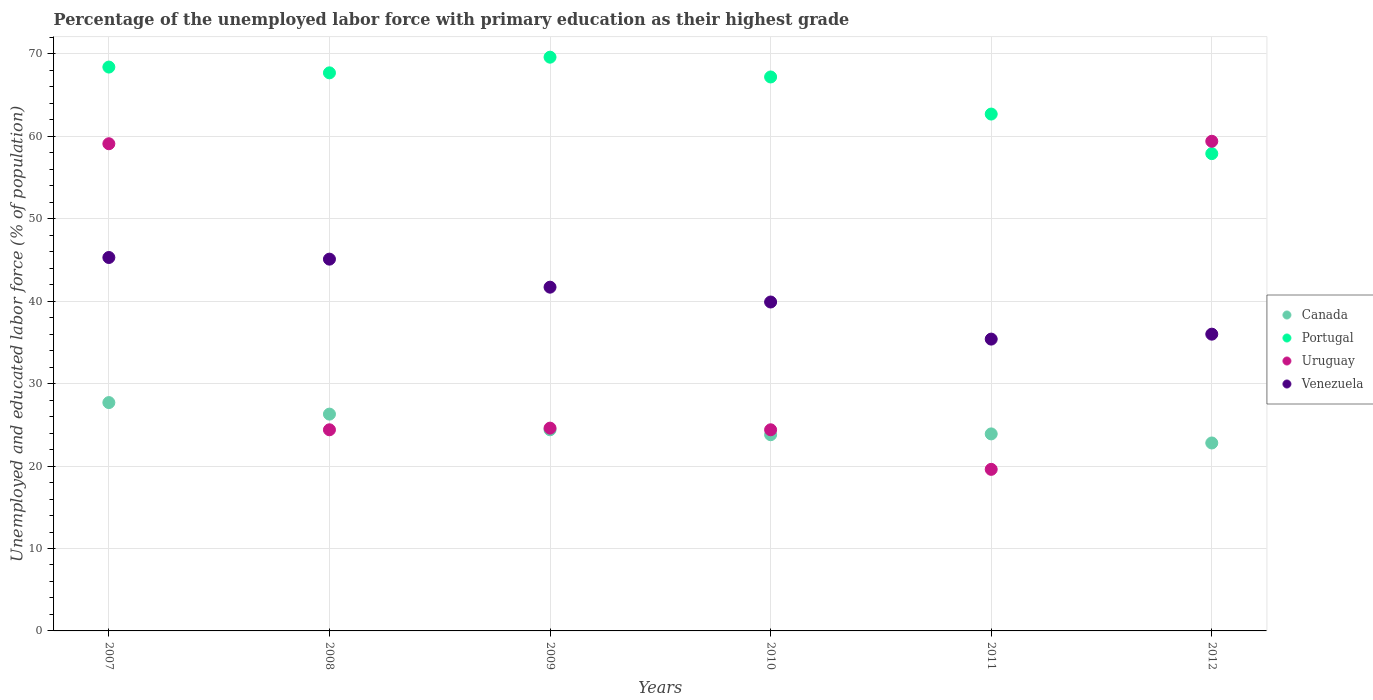How many different coloured dotlines are there?
Give a very brief answer. 4. What is the percentage of the unemployed labor force with primary education in Uruguay in 2008?
Give a very brief answer. 24.4. Across all years, what is the maximum percentage of the unemployed labor force with primary education in Portugal?
Give a very brief answer. 69.6. Across all years, what is the minimum percentage of the unemployed labor force with primary education in Canada?
Your response must be concise. 22.8. In which year was the percentage of the unemployed labor force with primary education in Canada maximum?
Offer a very short reply. 2007. What is the total percentage of the unemployed labor force with primary education in Uruguay in the graph?
Your answer should be very brief. 211.5. What is the difference between the percentage of the unemployed labor force with primary education in Uruguay in 2010 and that in 2011?
Offer a very short reply. 4.8. What is the difference between the percentage of the unemployed labor force with primary education in Uruguay in 2009 and the percentage of the unemployed labor force with primary education in Canada in 2007?
Give a very brief answer. -3.1. What is the average percentage of the unemployed labor force with primary education in Venezuela per year?
Give a very brief answer. 40.57. In the year 2011, what is the difference between the percentage of the unemployed labor force with primary education in Portugal and percentage of the unemployed labor force with primary education in Canada?
Offer a very short reply. 38.8. What is the ratio of the percentage of the unemployed labor force with primary education in Venezuela in 2007 to that in 2009?
Keep it short and to the point. 1.09. Is the percentage of the unemployed labor force with primary education in Portugal in 2009 less than that in 2012?
Offer a terse response. No. What is the difference between the highest and the second highest percentage of the unemployed labor force with primary education in Portugal?
Make the answer very short. 1.2. What is the difference between the highest and the lowest percentage of the unemployed labor force with primary education in Uruguay?
Your response must be concise. 39.8. In how many years, is the percentage of the unemployed labor force with primary education in Portugal greater than the average percentage of the unemployed labor force with primary education in Portugal taken over all years?
Offer a very short reply. 4. Is the sum of the percentage of the unemployed labor force with primary education in Canada in 2010 and 2012 greater than the maximum percentage of the unemployed labor force with primary education in Venezuela across all years?
Keep it short and to the point. Yes. Does the percentage of the unemployed labor force with primary education in Canada monotonically increase over the years?
Your answer should be compact. No. Is the percentage of the unemployed labor force with primary education in Uruguay strictly greater than the percentage of the unemployed labor force with primary education in Portugal over the years?
Keep it short and to the point. No. Is the percentage of the unemployed labor force with primary education in Canada strictly less than the percentage of the unemployed labor force with primary education in Portugal over the years?
Make the answer very short. Yes. How many dotlines are there?
Offer a terse response. 4. How many years are there in the graph?
Offer a terse response. 6. Does the graph contain grids?
Make the answer very short. Yes. Where does the legend appear in the graph?
Provide a succinct answer. Center right. How are the legend labels stacked?
Make the answer very short. Vertical. What is the title of the graph?
Provide a succinct answer. Percentage of the unemployed labor force with primary education as their highest grade. Does "Ukraine" appear as one of the legend labels in the graph?
Provide a short and direct response. No. What is the label or title of the Y-axis?
Offer a terse response. Unemployed and educated labor force (% of population). What is the Unemployed and educated labor force (% of population) of Canada in 2007?
Offer a terse response. 27.7. What is the Unemployed and educated labor force (% of population) of Portugal in 2007?
Give a very brief answer. 68.4. What is the Unemployed and educated labor force (% of population) of Uruguay in 2007?
Your response must be concise. 59.1. What is the Unemployed and educated labor force (% of population) of Venezuela in 2007?
Your response must be concise. 45.3. What is the Unemployed and educated labor force (% of population) in Canada in 2008?
Your answer should be compact. 26.3. What is the Unemployed and educated labor force (% of population) of Portugal in 2008?
Make the answer very short. 67.7. What is the Unemployed and educated labor force (% of population) in Uruguay in 2008?
Give a very brief answer. 24.4. What is the Unemployed and educated labor force (% of population) of Venezuela in 2008?
Provide a short and direct response. 45.1. What is the Unemployed and educated labor force (% of population) of Canada in 2009?
Your response must be concise. 24.4. What is the Unemployed and educated labor force (% of population) of Portugal in 2009?
Give a very brief answer. 69.6. What is the Unemployed and educated labor force (% of population) of Uruguay in 2009?
Ensure brevity in your answer.  24.6. What is the Unemployed and educated labor force (% of population) in Venezuela in 2009?
Your answer should be very brief. 41.7. What is the Unemployed and educated labor force (% of population) of Canada in 2010?
Your answer should be very brief. 23.8. What is the Unemployed and educated labor force (% of population) in Portugal in 2010?
Offer a terse response. 67.2. What is the Unemployed and educated labor force (% of population) of Uruguay in 2010?
Keep it short and to the point. 24.4. What is the Unemployed and educated labor force (% of population) of Venezuela in 2010?
Offer a terse response. 39.9. What is the Unemployed and educated labor force (% of population) in Canada in 2011?
Ensure brevity in your answer.  23.9. What is the Unemployed and educated labor force (% of population) of Portugal in 2011?
Give a very brief answer. 62.7. What is the Unemployed and educated labor force (% of population) of Uruguay in 2011?
Your response must be concise. 19.6. What is the Unemployed and educated labor force (% of population) in Venezuela in 2011?
Provide a succinct answer. 35.4. What is the Unemployed and educated labor force (% of population) in Canada in 2012?
Your response must be concise. 22.8. What is the Unemployed and educated labor force (% of population) of Portugal in 2012?
Your answer should be very brief. 57.9. What is the Unemployed and educated labor force (% of population) in Uruguay in 2012?
Offer a terse response. 59.4. Across all years, what is the maximum Unemployed and educated labor force (% of population) of Canada?
Make the answer very short. 27.7. Across all years, what is the maximum Unemployed and educated labor force (% of population) in Portugal?
Ensure brevity in your answer.  69.6. Across all years, what is the maximum Unemployed and educated labor force (% of population) of Uruguay?
Ensure brevity in your answer.  59.4. Across all years, what is the maximum Unemployed and educated labor force (% of population) of Venezuela?
Provide a short and direct response. 45.3. Across all years, what is the minimum Unemployed and educated labor force (% of population) of Canada?
Provide a short and direct response. 22.8. Across all years, what is the minimum Unemployed and educated labor force (% of population) of Portugal?
Keep it short and to the point. 57.9. Across all years, what is the minimum Unemployed and educated labor force (% of population) in Uruguay?
Offer a terse response. 19.6. Across all years, what is the minimum Unemployed and educated labor force (% of population) of Venezuela?
Offer a terse response. 35.4. What is the total Unemployed and educated labor force (% of population) of Canada in the graph?
Make the answer very short. 148.9. What is the total Unemployed and educated labor force (% of population) in Portugal in the graph?
Offer a very short reply. 393.5. What is the total Unemployed and educated labor force (% of population) in Uruguay in the graph?
Give a very brief answer. 211.5. What is the total Unemployed and educated labor force (% of population) in Venezuela in the graph?
Keep it short and to the point. 243.4. What is the difference between the Unemployed and educated labor force (% of population) in Uruguay in 2007 and that in 2008?
Keep it short and to the point. 34.7. What is the difference between the Unemployed and educated labor force (% of population) in Venezuela in 2007 and that in 2008?
Make the answer very short. 0.2. What is the difference between the Unemployed and educated labor force (% of population) in Canada in 2007 and that in 2009?
Offer a very short reply. 3.3. What is the difference between the Unemployed and educated labor force (% of population) of Uruguay in 2007 and that in 2009?
Your response must be concise. 34.5. What is the difference between the Unemployed and educated labor force (% of population) of Portugal in 2007 and that in 2010?
Keep it short and to the point. 1.2. What is the difference between the Unemployed and educated labor force (% of population) of Uruguay in 2007 and that in 2010?
Your answer should be compact. 34.7. What is the difference between the Unemployed and educated labor force (% of population) in Venezuela in 2007 and that in 2010?
Give a very brief answer. 5.4. What is the difference between the Unemployed and educated labor force (% of population) in Uruguay in 2007 and that in 2011?
Your answer should be very brief. 39.5. What is the difference between the Unemployed and educated labor force (% of population) of Portugal in 2007 and that in 2012?
Make the answer very short. 10.5. What is the difference between the Unemployed and educated labor force (% of population) of Uruguay in 2007 and that in 2012?
Your answer should be compact. -0.3. What is the difference between the Unemployed and educated labor force (% of population) in Portugal in 2008 and that in 2009?
Provide a short and direct response. -1.9. What is the difference between the Unemployed and educated labor force (% of population) of Uruguay in 2008 and that in 2009?
Your response must be concise. -0.2. What is the difference between the Unemployed and educated labor force (% of population) of Venezuela in 2008 and that in 2009?
Your response must be concise. 3.4. What is the difference between the Unemployed and educated labor force (% of population) in Canada in 2008 and that in 2010?
Your answer should be very brief. 2.5. What is the difference between the Unemployed and educated labor force (% of population) of Canada in 2008 and that in 2011?
Offer a terse response. 2.4. What is the difference between the Unemployed and educated labor force (% of population) in Portugal in 2008 and that in 2011?
Offer a very short reply. 5. What is the difference between the Unemployed and educated labor force (% of population) in Venezuela in 2008 and that in 2011?
Make the answer very short. 9.7. What is the difference between the Unemployed and educated labor force (% of population) in Canada in 2008 and that in 2012?
Offer a terse response. 3.5. What is the difference between the Unemployed and educated labor force (% of population) in Portugal in 2008 and that in 2012?
Ensure brevity in your answer.  9.8. What is the difference between the Unemployed and educated labor force (% of population) of Uruguay in 2008 and that in 2012?
Your answer should be compact. -35. What is the difference between the Unemployed and educated labor force (% of population) in Venezuela in 2008 and that in 2012?
Keep it short and to the point. 9.1. What is the difference between the Unemployed and educated labor force (% of population) in Canada in 2009 and that in 2010?
Your answer should be very brief. 0.6. What is the difference between the Unemployed and educated labor force (% of population) in Portugal in 2009 and that in 2010?
Offer a terse response. 2.4. What is the difference between the Unemployed and educated labor force (% of population) in Venezuela in 2009 and that in 2010?
Ensure brevity in your answer.  1.8. What is the difference between the Unemployed and educated labor force (% of population) in Canada in 2009 and that in 2011?
Keep it short and to the point. 0.5. What is the difference between the Unemployed and educated labor force (% of population) of Uruguay in 2009 and that in 2011?
Ensure brevity in your answer.  5. What is the difference between the Unemployed and educated labor force (% of population) of Uruguay in 2009 and that in 2012?
Provide a short and direct response. -34.8. What is the difference between the Unemployed and educated labor force (% of population) of Venezuela in 2009 and that in 2012?
Offer a very short reply. 5.7. What is the difference between the Unemployed and educated labor force (% of population) of Portugal in 2010 and that in 2012?
Ensure brevity in your answer.  9.3. What is the difference between the Unemployed and educated labor force (% of population) of Uruguay in 2010 and that in 2012?
Ensure brevity in your answer.  -35. What is the difference between the Unemployed and educated labor force (% of population) of Venezuela in 2010 and that in 2012?
Offer a terse response. 3.9. What is the difference between the Unemployed and educated labor force (% of population) in Uruguay in 2011 and that in 2012?
Provide a succinct answer. -39.8. What is the difference between the Unemployed and educated labor force (% of population) in Canada in 2007 and the Unemployed and educated labor force (% of population) in Portugal in 2008?
Offer a very short reply. -40. What is the difference between the Unemployed and educated labor force (% of population) of Canada in 2007 and the Unemployed and educated labor force (% of population) of Venezuela in 2008?
Provide a succinct answer. -17.4. What is the difference between the Unemployed and educated labor force (% of population) of Portugal in 2007 and the Unemployed and educated labor force (% of population) of Venezuela in 2008?
Your answer should be very brief. 23.3. What is the difference between the Unemployed and educated labor force (% of population) in Canada in 2007 and the Unemployed and educated labor force (% of population) in Portugal in 2009?
Offer a very short reply. -41.9. What is the difference between the Unemployed and educated labor force (% of population) of Canada in 2007 and the Unemployed and educated labor force (% of population) of Venezuela in 2009?
Your answer should be compact. -14. What is the difference between the Unemployed and educated labor force (% of population) in Portugal in 2007 and the Unemployed and educated labor force (% of population) in Uruguay in 2009?
Give a very brief answer. 43.8. What is the difference between the Unemployed and educated labor force (% of population) of Portugal in 2007 and the Unemployed and educated labor force (% of population) of Venezuela in 2009?
Provide a short and direct response. 26.7. What is the difference between the Unemployed and educated labor force (% of population) in Uruguay in 2007 and the Unemployed and educated labor force (% of population) in Venezuela in 2009?
Ensure brevity in your answer.  17.4. What is the difference between the Unemployed and educated labor force (% of population) of Canada in 2007 and the Unemployed and educated labor force (% of population) of Portugal in 2010?
Give a very brief answer. -39.5. What is the difference between the Unemployed and educated labor force (% of population) in Canada in 2007 and the Unemployed and educated labor force (% of population) in Venezuela in 2010?
Make the answer very short. -12.2. What is the difference between the Unemployed and educated labor force (% of population) in Uruguay in 2007 and the Unemployed and educated labor force (% of population) in Venezuela in 2010?
Ensure brevity in your answer.  19.2. What is the difference between the Unemployed and educated labor force (% of population) of Canada in 2007 and the Unemployed and educated labor force (% of population) of Portugal in 2011?
Offer a terse response. -35. What is the difference between the Unemployed and educated labor force (% of population) in Canada in 2007 and the Unemployed and educated labor force (% of population) in Uruguay in 2011?
Your answer should be compact. 8.1. What is the difference between the Unemployed and educated labor force (% of population) in Canada in 2007 and the Unemployed and educated labor force (% of population) in Venezuela in 2011?
Give a very brief answer. -7.7. What is the difference between the Unemployed and educated labor force (% of population) of Portugal in 2007 and the Unemployed and educated labor force (% of population) of Uruguay in 2011?
Offer a very short reply. 48.8. What is the difference between the Unemployed and educated labor force (% of population) of Portugal in 2007 and the Unemployed and educated labor force (% of population) of Venezuela in 2011?
Ensure brevity in your answer.  33. What is the difference between the Unemployed and educated labor force (% of population) of Uruguay in 2007 and the Unemployed and educated labor force (% of population) of Venezuela in 2011?
Give a very brief answer. 23.7. What is the difference between the Unemployed and educated labor force (% of population) in Canada in 2007 and the Unemployed and educated labor force (% of population) in Portugal in 2012?
Make the answer very short. -30.2. What is the difference between the Unemployed and educated labor force (% of population) of Canada in 2007 and the Unemployed and educated labor force (% of population) of Uruguay in 2012?
Keep it short and to the point. -31.7. What is the difference between the Unemployed and educated labor force (% of population) of Portugal in 2007 and the Unemployed and educated labor force (% of population) of Uruguay in 2012?
Provide a short and direct response. 9. What is the difference between the Unemployed and educated labor force (% of population) of Portugal in 2007 and the Unemployed and educated labor force (% of population) of Venezuela in 2012?
Offer a terse response. 32.4. What is the difference between the Unemployed and educated labor force (% of population) of Uruguay in 2007 and the Unemployed and educated labor force (% of population) of Venezuela in 2012?
Provide a short and direct response. 23.1. What is the difference between the Unemployed and educated labor force (% of population) in Canada in 2008 and the Unemployed and educated labor force (% of population) in Portugal in 2009?
Offer a very short reply. -43.3. What is the difference between the Unemployed and educated labor force (% of population) in Canada in 2008 and the Unemployed and educated labor force (% of population) in Uruguay in 2009?
Provide a succinct answer. 1.7. What is the difference between the Unemployed and educated labor force (% of population) of Canada in 2008 and the Unemployed and educated labor force (% of population) of Venezuela in 2009?
Make the answer very short. -15.4. What is the difference between the Unemployed and educated labor force (% of population) in Portugal in 2008 and the Unemployed and educated labor force (% of population) in Uruguay in 2009?
Your response must be concise. 43.1. What is the difference between the Unemployed and educated labor force (% of population) of Portugal in 2008 and the Unemployed and educated labor force (% of population) of Venezuela in 2009?
Your answer should be compact. 26. What is the difference between the Unemployed and educated labor force (% of population) in Uruguay in 2008 and the Unemployed and educated labor force (% of population) in Venezuela in 2009?
Offer a very short reply. -17.3. What is the difference between the Unemployed and educated labor force (% of population) of Canada in 2008 and the Unemployed and educated labor force (% of population) of Portugal in 2010?
Make the answer very short. -40.9. What is the difference between the Unemployed and educated labor force (% of population) in Canada in 2008 and the Unemployed and educated labor force (% of population) in Uruguay in 2010?
Keep it short and to the point. 1.9. What is the difference between the Unemployed and educated labor force (% of population) in Portugal in 2008 and the Unemployed and educated labor force (% of population) in Uruguay in 2010?
Provide a short and direct response. 43.3. What is the difference between the Unemployed and educated labor force (% of population) in Portugal in 2008 and the Unemployed and educated labor force (% of population) in Venezuela in 2010?
Make the answer very short. 27.8. What is the difference between the Unemployed and educated labor force (% of population) of Uruguay in 2008 and the Unemployed and educated labor force (% of population) of Venezuela in 2010?
Your response must be concise. -15.5. What is the difference between the Unemployed and educated labor force (% of population) in Canada in 2008 and the Unemployed and educated labor force (% of population) in Portugal in 2011?
Provide a succinct answer. -36.4. What is the difference between the Unemployed and educated labor force (% of population) in Portugal in 2008 and the Unemployed and educated labor force (% of population) in Uruguay in 2011?
Provide a succinct answer. 48.1. What is the difference between the Unemployed and educated labor force (% of population) of Portugal in 2008 and the Unemployed and educated labor force (% of population) of Venezuela in 2011?
Provide a succinct answer. 32.3. What is the difference between the Unemployed and educated labor force (% of population) of Uruguay in 2008 and the Unemployed and educated labor force (% of population) of Venezuela in 2011?
Keep it short and to the point. -11. What is the difference between the Unemployed and educated labor force (% of population) in Canada in 2008 and the Unemployed and educated labor force (% of population) in Portugal in 2012?
Provide a short and direct response. -31.6. What is the difference between the Unemployed and educated labor force (% of population) of Canada in 2008 and the Unemployed and educated labor force (% of population) of Uruguay in 2012?
Your answer should be very brief. -33.1. What is the difference between the Unemployed and educated labor force (% of population) in Portugal in 2008 and the Unemployed and educated labor force (% of population) in Uruguay in 2012?
Provide a short and direct response. 8.3. What is the difference between the Unemployed and educated labor force (% of population) in Portugal in 2008 and the Unemployed and educated labor force (% of population) in Venezuela in 2012?
Your response must be concise. 31.7. What is the difference between the Unemployed and educated labor force (% of population) in Uruguay in 2008 and the Unemployed and educated labor force (% of population) in Venezuela in 2012?
Your answer should be compact. -11.6. What is the difference between the Unemployed and educated labor force (% of population) of Canada in 2009 and the Unemployed and educated labor force (% of population) of Portugal in 2010?
Ensure brevity in your answer.  -42.8. What is the difference between the Unemployed and educated labor force (% of population) in Canada in 2009 and the Unemployed and educated labor force (% of population) in Uruguay in 2010?
Ensure brevity in your answer.  0. What is the difference between the Unemployed and educated labor force (% of population) of Canada in 2009 and the Unemployed and educated labor force (% of population) of Venezuela in 2010?
Offer a terse response. -15.5. What is the difference between the Unemployed and educated labor force (% of population) in Portugal in 2009 and the Unemployed and educated labor force (% of population) in Uruguay in 2010?
Make the answer very short. 45.2. What is the difference between the Unemployed and educated labor force (% of population) in Portugal in 2009 and the Unemployed and educated labor force (% of population) in Venezuela in 2010?
Ensure brevity in your answer.  29.7. What is the difference between the Unemployed and educated labor force (% of population) of Uruguay in 2009 and the Unemployed and educated labor force (% of population) of Venezuela in 2010?
Provide a short and direct response. -15.3. What is the difference between the Unemployed and educated labor force (% of population) of Canada in 2009 and the Unemployed and educated labor force (% of population) of Portugal in 2011?
Offer a terse response. -38.3. What is the difference between the Unemployed and educated labor force (% of population) of Portugal in 2009 and the Unemployed and educated labor force (% of population) of Venezuela in 2011?
Your response must be concise. 34.2. What is the difference between the Unemployed and educated labor force (% of population) of Uruguay in 2009 and the Unemployed and educated labor force (% of population) of Venezuela in 2011?
Provide a short and direct response. -10.8. What is the difference between the Unemployed and educated labor force (% of population) in Canada in 2009 and the Unemployed and educated labor force (% of population) in Portugal in 2012?
Give a very brief answer. -33.5. What is the difference between the Unemployed and educated labor force (% of population) of Canada in 2009 and the Unemployed and educated labor force (% of population) of Uruguay in 2012?
Give a very brief answer. -35. What is the difference between the Unemployed and educated labor force (% of population) of Portugal in 2009 and the Unemployed and educated labor force (% of population) of Uruguay in 2012?
Your response must be concise. 10.2. What is the difference between the Unemployed and educated labor force (% of population) in Portugal in 2009 and the Unemployed and educated labor force (% of population) in Venezuela in 2012?
Provide a succinct answer. 33.6. What is the difference between the Unemployed and educated labor force (% of population) in Uruguay in 2009 and the Unemployed and educated labor force (% of population) in Venezuela in 2012?
Offer a terse response. -11.4. What is the difference between the Unemployed and educated labor force (% of population) in Canada in 2010 and the Unemployed and educated labor force (% of population) in Portugal in 2011?
Ensure brevity in your answer.  -38.9. What is the difference between the Unemployed and educated labor force (% of population) in Canada in 2010 and the Unemployed and educated labor force (% of population) in Uruguay in 2011?
Offer a terse response. 4.2. What is the difference between the Unemployed and educated labor force (% of population) in Portugal in 2010 and the Unemployed and educated labor force (% of population) in Uruguay in 2011?
Make the answer very short. 47.6. What is the difference between the Unemployed and educated labor force (% of population) of Portugal in 2010 and the Unemployed and educated labor force (% of population) of Venezuela in 2011?
Provide a succinct answer. 31.8. What is the difference between the Unemployed and educated labor force (% of population) in Uruguay in 2010 and the Unemployed and educated labor force (% of population) in Venezuela in 2011?
Provide a short and direct response. -11. What is the difference between the Unemployed and educated labor force (% of population) of Canada in 2010 and the Unemployed and educated labor force (% of population) of Portugal in 2012?
Your response must be concise. -34.1. What is the difference between the Unemployed and educated labor force (% of population) in Canada in 2010 and the Unemployed and educated labor force (% of population) in Uruguay in 2012?
Provide a short and direct response. -35.6. What is the difference between the Unemployed and educated labor force (% of population) in Canada in 2010 and the Unemployed and educated labor force (% of population) in Venezuela in 2012?
Your answer should be very brief. -12.2. What is the difference between the Unemployed and educated labor force (% of population) in Portugal in 2010 and the Unemployed and educated labor force (% of population) in Uruguay in 2012?
Give a very brief answer. 7.8. What is the difference between the Unemployed and educated labor force (% of population) in Portugal in 2010 and the Unemployed and educated labor force (% of population) in Venezuela in 2012?
Make the answer very short. 31.2. What is the difference between the Unemployed and educated labor force (% of population) of Uruguay in 2010 and the Unemployed and educated labor force (% of population) of Venezuela in 2012?
Your response must be concise. -11.6. What is the difference between the Unemployed and educated labor force (% of population) in Canada in 2011 and the Unemployed and educated labor force (% of population) in Portugal in 2012?
Your answer should be compact. -34. What is the difference between the Unemployed and educated labor force (% of population) of Canada in 2011 and the Unemployed and educated labor force (% of population) of Uruguay in 2012?
Make the answer very short. -35.5. What is the difference between the Unemployed and educated labor force (% of population) in Canada in 2011 and the Unemployed and educated labor force (% of population) in Venezuela in 2012?
Offer a terse response. -12.1. What is the difference between the Unemployed and educated labor force (% of population) of Portugal in 2011 and the Unemployed and educated labor force (% of population) of Venezuela in 2012?
Offer a terse response. 26.7. What is the difference between the Unemployed and educated labor force (% of population) in Uruguay in 2011 and the Unemployed and educated labor force (% of population) in Venezuela in 2012?
Your response must be concise. -16.4. What is the average Unemployed and educated labor force (% of population) of Canada per year?
Offer a terse response. 24.82. What is the average Unemployed and educated labor force (% of population) in Portugal per year?
Give a very brief answer. 65.58. What is the average Unemployed and educated labor force (% of population) of Uruguay per year?
Offer a terse response. 35.25. What is the average Unemployed and educated labor force (% of population) of Venezuela per year?
Make the answer very short. 40.57. In the year 2007, what is the difference between the Unemployed and educated labor force (% of population) in Canada and Unemployed and educated labor force (% of population) in Portugal?
Keep it short and to the point. -40.7. In the year 2007, what is the difference between the Unemployed and educated labor force (% of population) in Canada and Unemployed and educated labor force (% of population) in Uruguay?
Make the answer very short. -31.4. In the year 2007, what is the difference between the Unemployed and educated labor force (% of population) of Canada and Unemployed and educated labor force (% of population) of Venezuela?
Your answer should be very brief. -17.6. In the year 2007, what is the difference between the Unemployed and educated labor force (% of population) of Portugal and Unemployed and educated labor force (% of population) of Uruguay?
Make the answer very short. 9.3. In the year 2007, what is the difference between the Unemployed and educated labor force (% of population) in Portugal and Unemployed and educated labor force (% of population) in Venezuela?
Your answer should be compact. 23.1. In the year 2008, what is the difference between the Unemployed and educated labor force (% of population) in Canada and Unemployed and educated labor force (% of population) in Portugal?
Ensure brevity in your answer.  -41.4. In the year 2008, what is the difference between the Unemployed and educated labor force (% of population) in Canada and Unemployed and educated labor force (% of population) in Uruguay?
Give a very brief answer. 1.9. In the year 2008, what is the difference between the Unemployed and educated labor force (% of population) of Canada and Unemployed and educated labor force (% of population) of Venezuela?
Provide a succinct answer. -18.8. In the year 2008, what is the difference between the Unemployed and educated labor force (% of population) in Portugal and Unemployed and educated labor force (% of population) in Uruguay?
Offer a very short reply. 43.3. In the year 2008, what is the difference between the Unemployed and educated labor force (% of population) in Portugal and Unemployed and educated labor force (% of population) in Venezuela?
Your answer should be very brief. 22.6. In the year 2008, what is the difference between the Unemployed and educated labor force (% of population) in Uruguay and Unemployed and educated labor force (% of population) in Venezuela?
Offer a very short reply. -20.7. In the year 2009, what is the difference between the Unemployed and educated labor force (% of population) in Canada and Unemployed and educated labor force (% of population) in Portugal?
Your answer should be very brief. -45.2. In the year 2009, what is the difference between the Unemployed and educated labor force (% of population) of Canada and Unemployed and educated labor force (% of population) of Venezuela?
Provide a succinct answer. -17.3. In the year 2009, what is the difference between the Unemployed and educated labor force (% of population) in Portugal and Unemployed and educated labor force (% of population) in Venezuela?
Your answer should be compact. 27.9. In the year 2009, what is the difference between the Unemployed and educated labor force (% of population) of Uruguay and Unemployed and educated labor force (% of population) of Venezuela?
Your answer should be compact. -17.1. In the year 2010, what is the difference between the Unemployed and educated labor force (% of population) of Canada and Unemployed and educated labor force (% of population) of Portugal?
Make the answer very short. -43.4. In the year 2010, what is the difference between the Unemployed and educated labor force (% of population) in Canada and Unemployed and educated labor force (% of population) in Uruguay?
Your answer should be compact. -0.6. In the year 2010, what is the difference between the Unemployed and educated labor force (% of population) of Canada and Unemployed and educated labor force (% of population) of Venezuela?
Give a very brief answer. -16.1. In the year 2010, what is the difference between the Unemployed and educated labor force (% of population) in Portugal and Unemployed and educated labor force (% of population) in Uruguay?
Offer a terse response. 42.8. In the year 2010, what is the difference between the Unemployed and educated labor force (% of population) in Portugal and Unemployed and educated labor force (% of population) in Venezuela?
Make the answer very short. 27.3. In the year 2010, what is the difference between the Unemployed and educated labor force (% of population) of Uruguay and Unemployed and educated labor force (% of population) of Venezuela?
Provide a succinct answer. -15.5. In the year 2011, what is the difference between the Unemployed and educated labor force (% of population) of Canada and Unemployed and educated labor force (% of population) of Portugal?
Your response must be concise. -38.8. In the year 2011, what is the difference between the Unemployed and educated labor force (% of population) in Canada and Unemployed and educated labor force (% of population) in Uruguay?
Ensure brevity in your answer.  4.3. In the year 2011, what is the difference between the Unemployed and educated labor force (% of population) in Portugal and Unemployed and educated labor force (% of population) in Uruguay?
Make the answer very short. 43.1. In the year 2011, what is the difference between the Unemployed and educated labor force (% of population) in Portugal and Unemployed and educated labor force (% of population) in Venezuela?
Give a very brief answer. 27.3. In the year 2011, what is the difference between the Unemployed and educated labor force (% of population) of Uruguay and Unemployed and educated labor force (% of population) of Venezuela?
Keep it short and to the point. -15.8. In the year 2012, what is the difference between the Unemployed and educated labor force (% of population) in Canada and Unemployed and educated labor force (% of population) in Portugal?
Make the answer very short. -35.1. In the year 2012, what is the difference between the Unemployed and educated labor force (% of population) of Canada and Unemployed and educated labor force (% of population) of Uruguay?
Ensure brevity in your answer.  -36.6. In the year 2012, what is the difference between the Unemployed and educated labor force (% of population) in Canada and Unemployed and educated labor force (% of population) in Venezuela?
Keep it short and to the point. -13.2. In the year 2012, what is the difference between the Unemployed and educated labor force (% of population) in Portugal and Unemployed and educated labor force (% of population) in Venezuela?
Offer a very short reply. 21.9. In the year 2012, what is the difference between the Unemployed and educated labor force (% of population) of Uruguay and Unemployed and educated labor force (% of population) of Venezuela?
Provide a succinct answer. 23.4. What is the ratio of the Unemployed and educated labor force (% of population) in Canada in 2007 to that in 2008?
Offer a very short reply. 1.05. What is the ratio of the Unemployed and educated labor force (% of population) of Portugal in 2007 to that in 2008?
Your answer should be compact. 1.01. What is the ratio of the Unemployed and educated labor force (% of population) in Uruguay in 2007 to that in 2008?
Make the answer very short. 2.42. What is the ratio of the Unemployed and educated labor force (% of population) in Canada in 2007 to that in 2009?
Give a very brief answer. 1.14. What is the ratio of the Unemployed and educated labor force (% of population) of Portugal in 2007 to that in 2009?
Provide a succinct answer. 0.98. What is the ratio of the Unemployed and educated labor force (% of population) of Uruguay in 2007 to that in 2009?
Offer a very short reply. 2.4. What is the ratio of the Unemployed and educated labor force (% of population) in Venezuela in 2007 to that in 2009?
Your answer should be very brief. 1.09. What is the ratio of the Unemployed and educated labor force (% of population) of Canada in 2007 to that in 2010?
Your answer should be very brief. 1.16. What is the ratio of the Unemployed and educated labor force (% of population) of Portugal in 2007 to that in 2010?
Offer a very short reply. 1.02. What is the ratio of the Unemployed and educated labor force (% of population) in Uruguay in 2007 to that in 2010?
Your answer should be compact. 2.42. What is the ratio of the Unemployed and educated labor force (% of population) in Venezuela in 2007 to that in 2010?
Your answer should be compact. 1.14. What is the ratio of the Unemployed and educated labor force (% of population) in Canada in 2007 to that in 2011?
Give a very brief answer. 1.16. What is the ratio of the Unemployed and educated labor force (% of population) in Portugal in 2007 to that in 2011?
Your response must be concise. 1.09. What is the ratio of the Unemployed and educated labor force (% of population) of Uruguay in 2007 to that in 2011?
Keep it short and to the point. 3.02. What is the ratio of the Unemployed and educated labor force (% of population) in Venezuela in 2007 to that in 2011?
Give a very brief answer. 1.28. What is the ratio of the Unemployed and educated labor force (% of population) of Canada in 2007 to that in 2012?
Provide a short and direct response. 1.21. What is the ratio of the Unemployed and educated labor force (% of population) in Portugal in 2007 to that in 2012?
Provide a succinct answer. 1.18. What is the ratio of the Unemployed and educated labor force (% of population) of Venezuela in 2007 to that in 2012?
Offer a terse response. 1.26. What is the ratio of the Unemployed and educated labor force (% of population) in Canada in 2008 to that in 2009?
Make the answer very short. 1.08. What is the ratio of the Unemployed and educated labor force (% of population) of Portugal in 2008 to that in 2009?
Your answer should be compact. 0.97. What is the ratio of the Unemployed and educated labor force (% of population) in Venezuela in 2008 to that in 2009?
Offer a terse response. 1.08. What is the ratio of the Unemployed and educated labor force (% of population) in Canada in 2008 to that in 2010?
Offer a very short reply. 1.1. What is the ratio of the Unemployed and educated labor force (% of population) of Portugal in 2008 to that in 2010?
Keep it short and to the point. 1.01. What is the ratio of the Unemployed and educated labor force (% of population) in Venezuela in 2008 to that in 2010?
Your answer should be very brief. 1.13. What is the ratio of the Unemployed and educated labor force (% of population) in Canada in 2008 to that in 2011?
Provide a succinct answer. 1.1. What is the ratio of the Unemployed and educated labor force (% of population) of Portugal in 2008 to that in 2011?
Keep it short and to the point. 1.08. What is the ratio of the Unemployed and educated labor force (% of population) of Uruguay in 2008 to that in 2011?
Provide a succinct answer. 1.24. What is the ratio of the Unemployed and educated labor force (% of population) of Venezuela in 2008 to that in 2011?
Offer a very short reply. 1.27. What is the ratio of the Unemployed and educated labor force (% of population) in Canada in 2008 to that in 2012?
Keep it short and to the point. 1.15. What is the ratio of the Unemployed and educated labor force (% of population) of Portugal in 2008 to that in 2012?
Make the answer very short. 1.17. What is the ratio of the Unemployed and educated labor force (% of population) in Uruguay in 2008 to that in 2012?
Offer a very short reply. 0.41. What is the ratio of the Unemployed and educated labor force (% of population) in Venezuela in 2008 to that in 2012?
Your response must be concise. 1.25. What is the ratio of the Unemployed and educated labor force (% of population) of Canada in 2009 to that in 2010?
Ensure brevity in your answer.  1.03. What is the ratio of the Unemployed and educated labor force (% of population) of Portugal in 2009 to that in 2010?
Give a very brief answer. 1.04. What is the ratio of the Unemployed and educated labor force (% of population) of Uruguay in 2009 to that in 2010?
Make the answer very short. 1.01. What is the ratio of the Unemployed and educated labor force (% of population) in Venezuela in 2009 to that in 2010?
Keep it short and to the point. 1.05. What is the ratio of the Unemployed and educated labor force (% of population) in Canada in 2009 to that in 2011?
Your response must be concise. 1.02. What is the ratio of the Unemployed and educated labor force (% of population) in Portugal in 2009 to that in 2011?
Provide a short and direct response. 1.11. What is the ratio of the Unemployed and educated labor force (% of population) in Uruguay in 2009 to that in 2011?
Keep it short and to the point. 1.26. What is the ratio of the Unemployed and educated labor force (% of population) of Venezuela in 2009 to that in 2011?
Give a very brief answer. 1.18. What is the ratio of the Unemployed and educated labor force (% of population) in Canada in 2009 to that in 2012?
Offer a terse response. 1.07. What is the ratio of the Unemployed and educated labor force (% of population) of Portugal in 2009 to that in 2012?
Provide a short and direct response. 1.2. What is the ratio of the Unemployed and educated labor force (% of population) of Uruguay in 2009 to that in 2012?
Your answer should be compact. 0.41. What is the ratio of the Unemployed and educated labor force (% of population) of Venezuela in 2009 to that in 2012?
Provide a short and direct response. 1.16. What is the ratio of the Unemployed and educated labor force (% of population) in Canada in 2010 to that in 2011?
Your response must be concise. 1. What is the ratio of the Unemployed and educated labor force (% of population) of Portugal in 2010 to that in 2011?
Your answer should be compact. 1.07. What is the ratio of the Unemployed and educated labor force (% of population) in Uruguay in 2010 to that in 2011?
Your response must be concise. 1.24. What is the ratio of the Unemployed and educated labor force (% of population) of Venezuela in 2010 to that in 2011?
Provide a succinct answer. 1.13. What is the ratio of the Unemployed and educated labor force (% of population) in Canada in 2010 to that in 2012?
Your response must be concise. 1.04. What is the ratio of the Unemployed and educated labor force (% of population) in Portugal in 2010 to that in 2012?
Your response must be concise. 1.16. What is the ratio of the Unemployed and educated labor force (% of population) in Uruguay in 2010 to that in 2012?
Offer a terse response. 0.41. What is the ratio of the Unemployed and educated labor force (% of population) of Venezuela in 2010 to that in 2012?
Offer a very short reply. 1.11. What is the ratio of the Unemployed and educated labor force (% of population) of Canada in 2011 to that in 2012?
Make the answer very short. 1.05. What is the ratio of the Unemployed and educated labor force (% of population) in Portugal in 2011 to that in 2012?
Your response must be concise. 1.08. What is the ratio of the Unemployed and educated labor force (% of population) in Uruguay in 2011 to that in 2012?
Provide a short and direct response. 0.33. What is the ratio of the Unemployed and educated labor force (% of population) of Venezuela in 2011 to that in 2012?
Your response must be concise. 0.98. What is the difference between the highest and the lowest Unemployed and educated labor force (% of population) in Uruguay?
Ensure brevity in your answer.  39.8. 